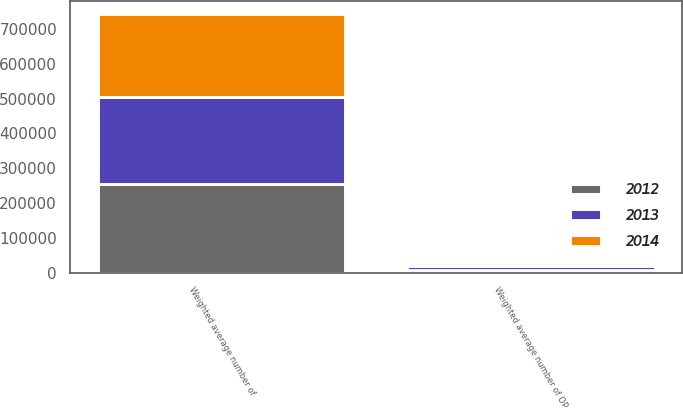Convert chart. <chart><loc_0><loc_0><loc_500><loc_500><stacked_bar_chart><ecel><fcel>Weighted average number of<fcel>Weighted average number of OP<nl><fcel>2012<fcel>253445<fcel>9247<nl><fcel>2013<fcel>249969<fcel>9337<nl><fcel>2014<fcel>238851<fcel>9411<nl></chart> 